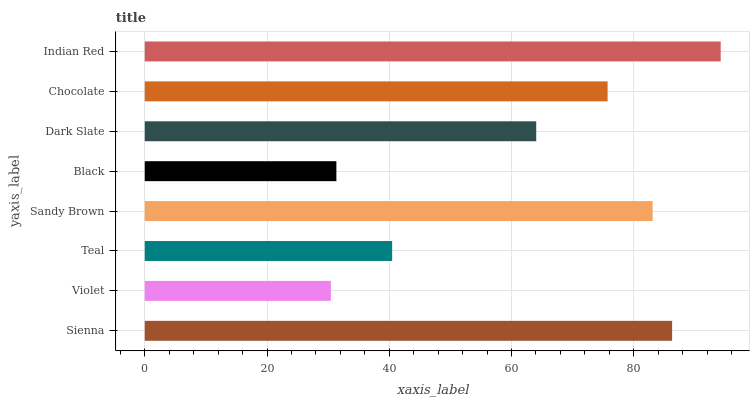Is Violet the minimum?
Answer yes or no. Yes. Is Indian Red the maximum?
Answer yes or no. Yes. Is Teal the minimum?
Answer yes or no. No. Is Teal the maximum?
Answer yes or no. No. Is Teal greater than Violet?
Answer yes or no. Yes. Is Violet less than Teal?
Answer yes or no. Yes. Is Violet greater than Teal?
Answer yes or no. No. Is Teal less than Violet?
Answer yes or no. No. Is Chocolate the high median?
Answer yes or no. Yes. Is Dark Slate the low median?
Answer yes or no. Yes. Is Sienna the high median?
Answer yes or no. No. Is Black the low median?
Answer yes or no. No. 